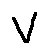Convert formula to latex. <formula><loc_0><loc_0><loc_500><loc_500>v</formula> 